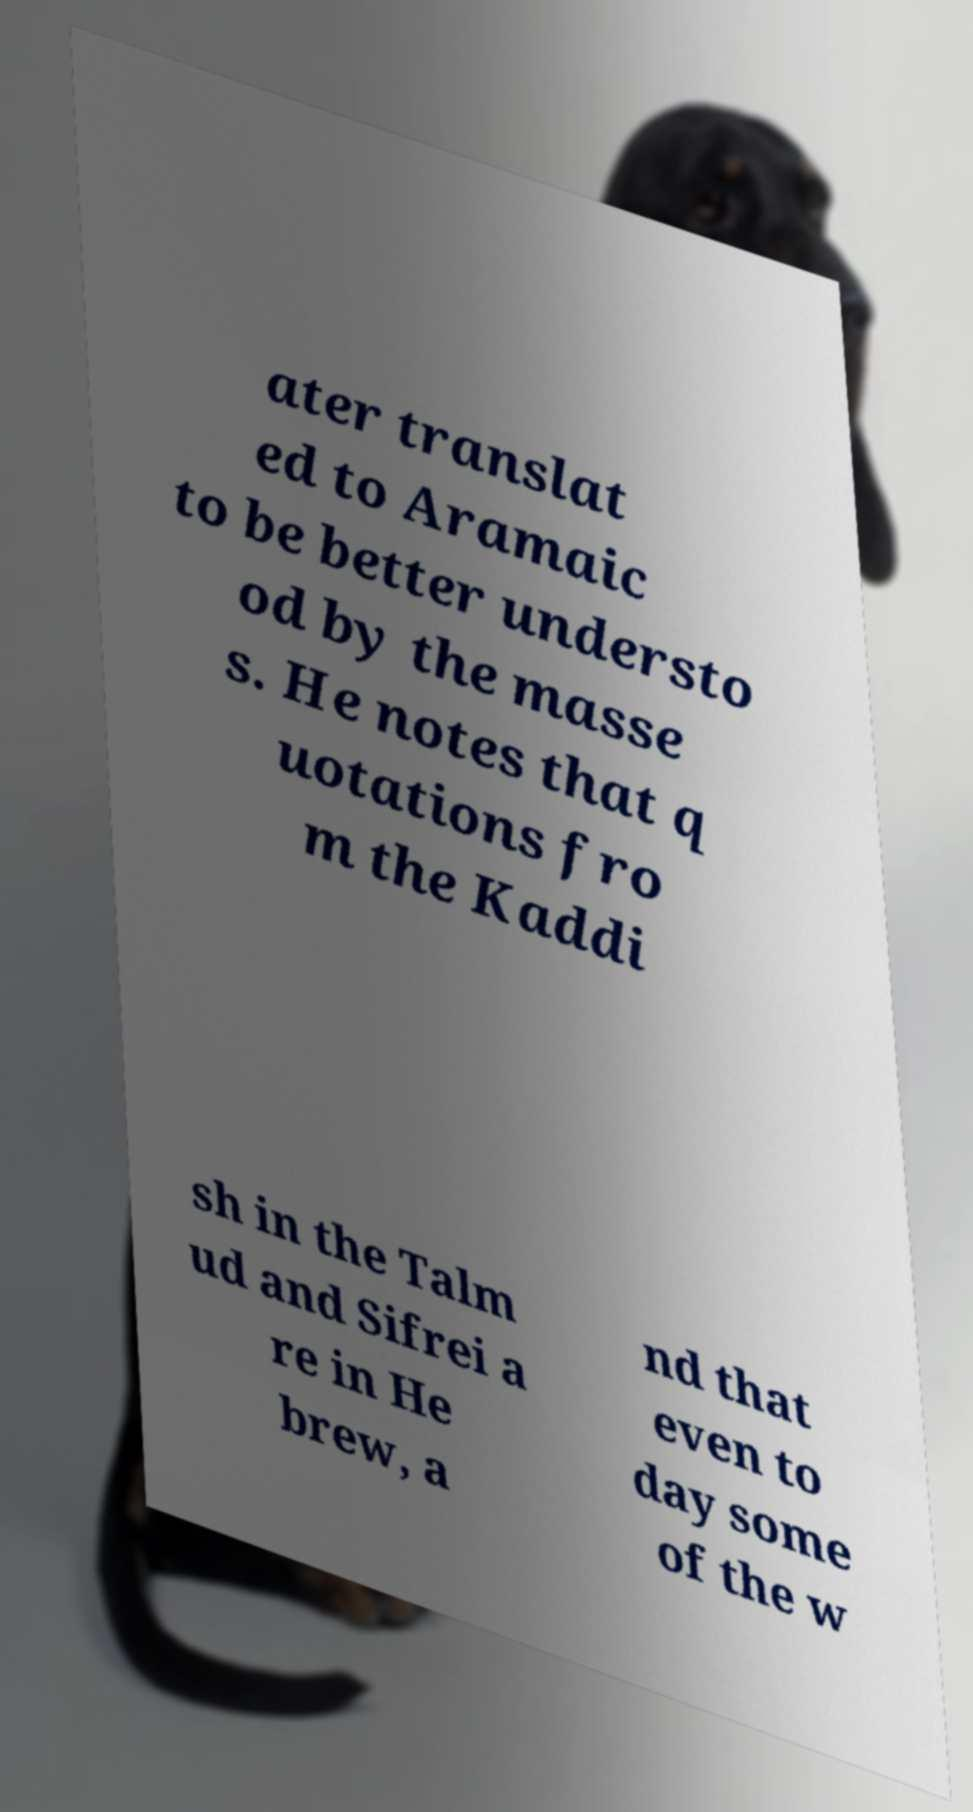There's text embedded in this image that I need extracted. Can you transcribe it verbatim? ater translat ed to Aramaic to be better understo od by the masse s. He notes that q uotations fro m the Kaddi sh in the Talm ud and Sifrei a re in He brew, a nd that even to day some of the w 